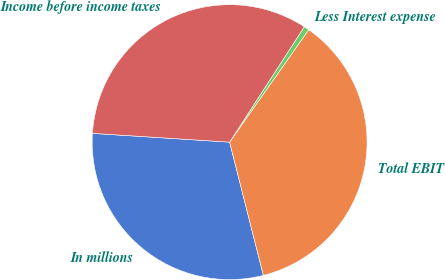Convert chart to OTSL. <chart><loc_0><loc_0><loc_500><loc_500><pie_chart><fcel>In millions<fcel>Total EBIT<fcel>Less Interest expense<fcel>Income before income taxes<nl><fcel>29.97%<fcel>36.29%<fcel>0.61%<fcel>33.13%<nl></chart> 